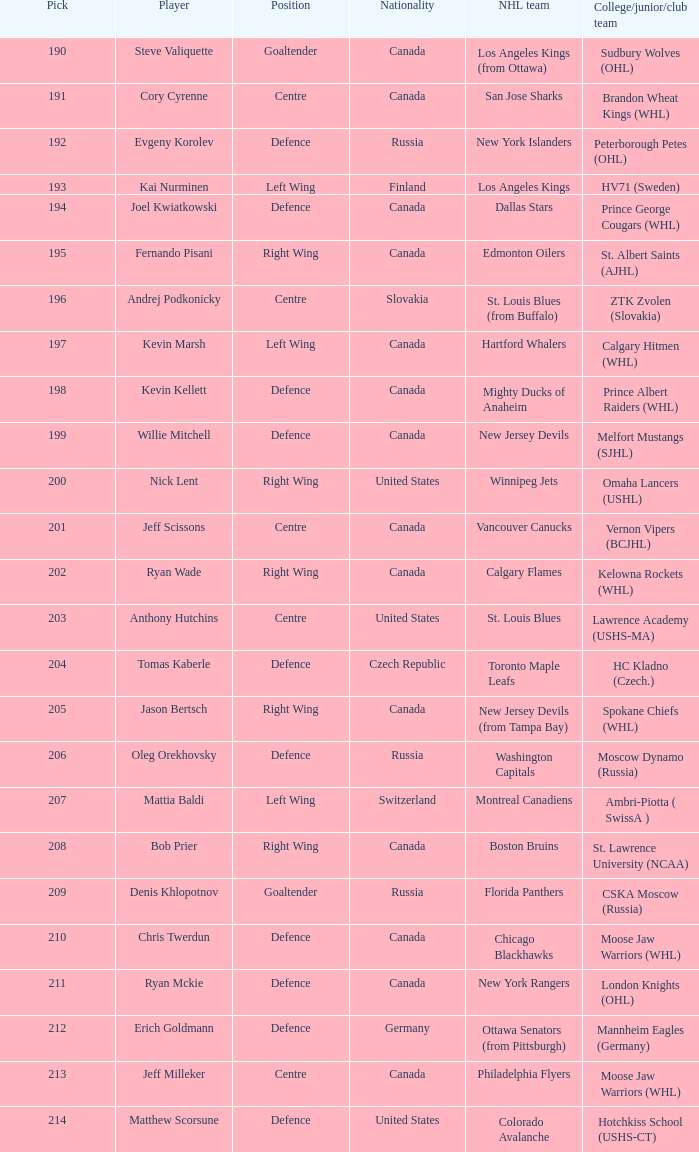What is the college associated with andrej podkonicky? ZTK Zvolen (Slovakia). 